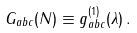Convert formula to latex. <formula><loc_0><loc_0><loc_500><loc_500>G _ { a b c } ( N ) \equiv g ^ { ( 1 ) } _ { a b c } ( \lambda ) \, .</formula> 